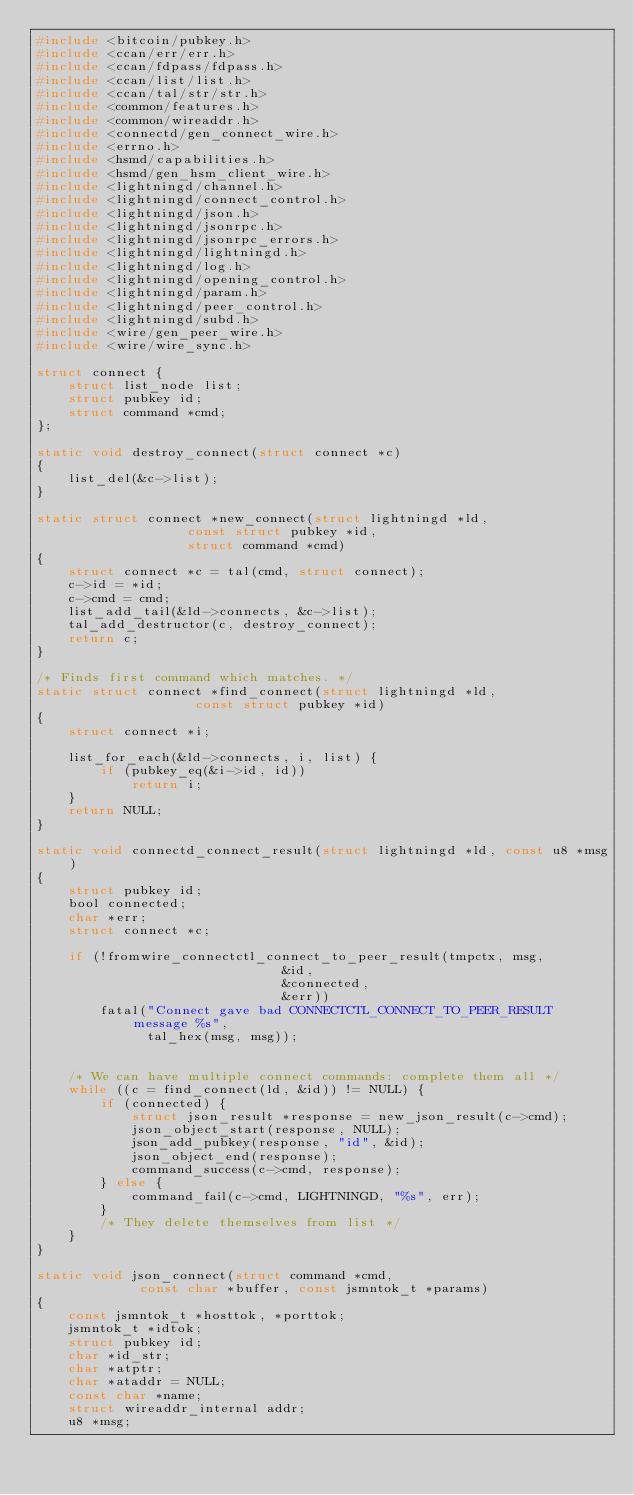Convert code to text. <code><loc_0><loc_0><loc_500><loc_500><_C_>#include <bitcoin/pubkey.h>
#include <ccan/err/err.h>
#include <ccan/fdpass/fdpass.h>
#include <ccan/list/list.h>
#include <ccan/tal/str/str.h>
#include <common/features.h>
#include <common/wireaddr.h>
#include <connectd/gen_connect_wire.h>
#include <errno.h>
#include <hsmd/capabilities.h>
#include <hsmd/gen_hsm_client_wire.h>
#include <lightningd/channel.h>
#include <lightningd/connect_control.h>
#include <lightningd/json.h>
#include <lightningd/jsonrpc.h>
#include <lightningd/jsonrpc_errors.h>
#include <lightningd/lightningd.h>
#include <lightningd/log.h>
#include <lightningd/opening_control.h>
#include <lightningd/param.h>
#include <lightningd/peer_control.h>
#include <lightningd/subd.h>
#include <wire/gen_peer_wire.h>
#include <wire/wire_sync.h>

struct connect {
	struct list_node list;
	struct pubkey id;
	struct command *cmd;
};

static void destroy_connect(struct connect *c)
{
	list_del(&c->list);
}

static struct connect *new_connect(struct lightningd *ld,
				   const struct pubkey *id,
				   struct command *cmd)
{
	struct connect *c = tal(cmd, struct connect);
	c->id = *id;
	c->cmd = cmd;
	list_add_tail(&ld->connects, &c->list);
	tal_add_destructor(c, destroy_connect);
	return c;
}

/* Finds first command which matches. */
static struct connect *find_connect(struct lightningd *ld,
				    const struct pubkey *id)
{
	struct connect *i;

	list_for_each(&ld->connects, i, list) {
		if (pubkey_eq(&i->id, id))
			return i;
	}
	return NULL;
}

static void connectd_connect_result(struct lightningd *ld, const u8 *msg)
{
	struct pubkey id;
	bool connected;
	char *err;
	struct connect *c;

	if (!fromwire_connectctl_connect_to_peer_result(tmpctx, msg,
						       &id,
						       &connected,
						       &err))
		fatal("Connect gave bad CONNECTCTL_CONNECT_TO_PEER_RESULT message %s",
		      tal_hex(msg, msg));


	/* We can have multiple connect commands: complete them all */
	while ((c = find_connect(ld, &id)) != NULL) {
		if (connected) {
			struct json_result *response = new_json_result(c->cmd);
			json_object_start(response, NULL);
			json_add_pubkey(response, "id", &id);
			json_object_end(response);
			command_success(c->cmd, response);
		} else {
			command_fail(c->cmd, LIGHTNINGD, "%s", err);
		}
		/* They delete themselves from list */
	}
}

static void json_connect(struct command *cmd,
			 const char *buffer, const jsmntok_t *params)
{
	const jsmntok_t *hosttok, *porttok;
	jsmntok_t *idtok;
	struct pubkey id;
	char *id_str;
	char *atptr;
	char *ataddr = NULL;
	const char *name;
	struct wireaddr_internal addr;
	u8 *msg;</code> 